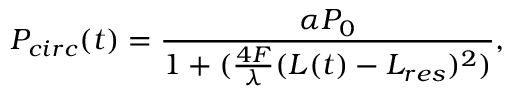Convert formula to latex. <formula><loc_0><loc_0><loc_500><loc_500>P _ { c i r c } ( t ) = \frac { \alpha P _ { 0 } } { 1 + ( \frac { 4 F } { \lambda } ( L ( t ) - L _ { r e s } ) ^ { 2 } ) } ,</formula> 